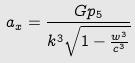<formula> <loc_0><loc_0><loc_500><loc_500>a _ { x } = \frac { G p _ { 5 } } { k ^ { 3 } \sqrt { 1 - \frac { w ^ { 3 } } { c ^ { 3 } } } }</formula> 